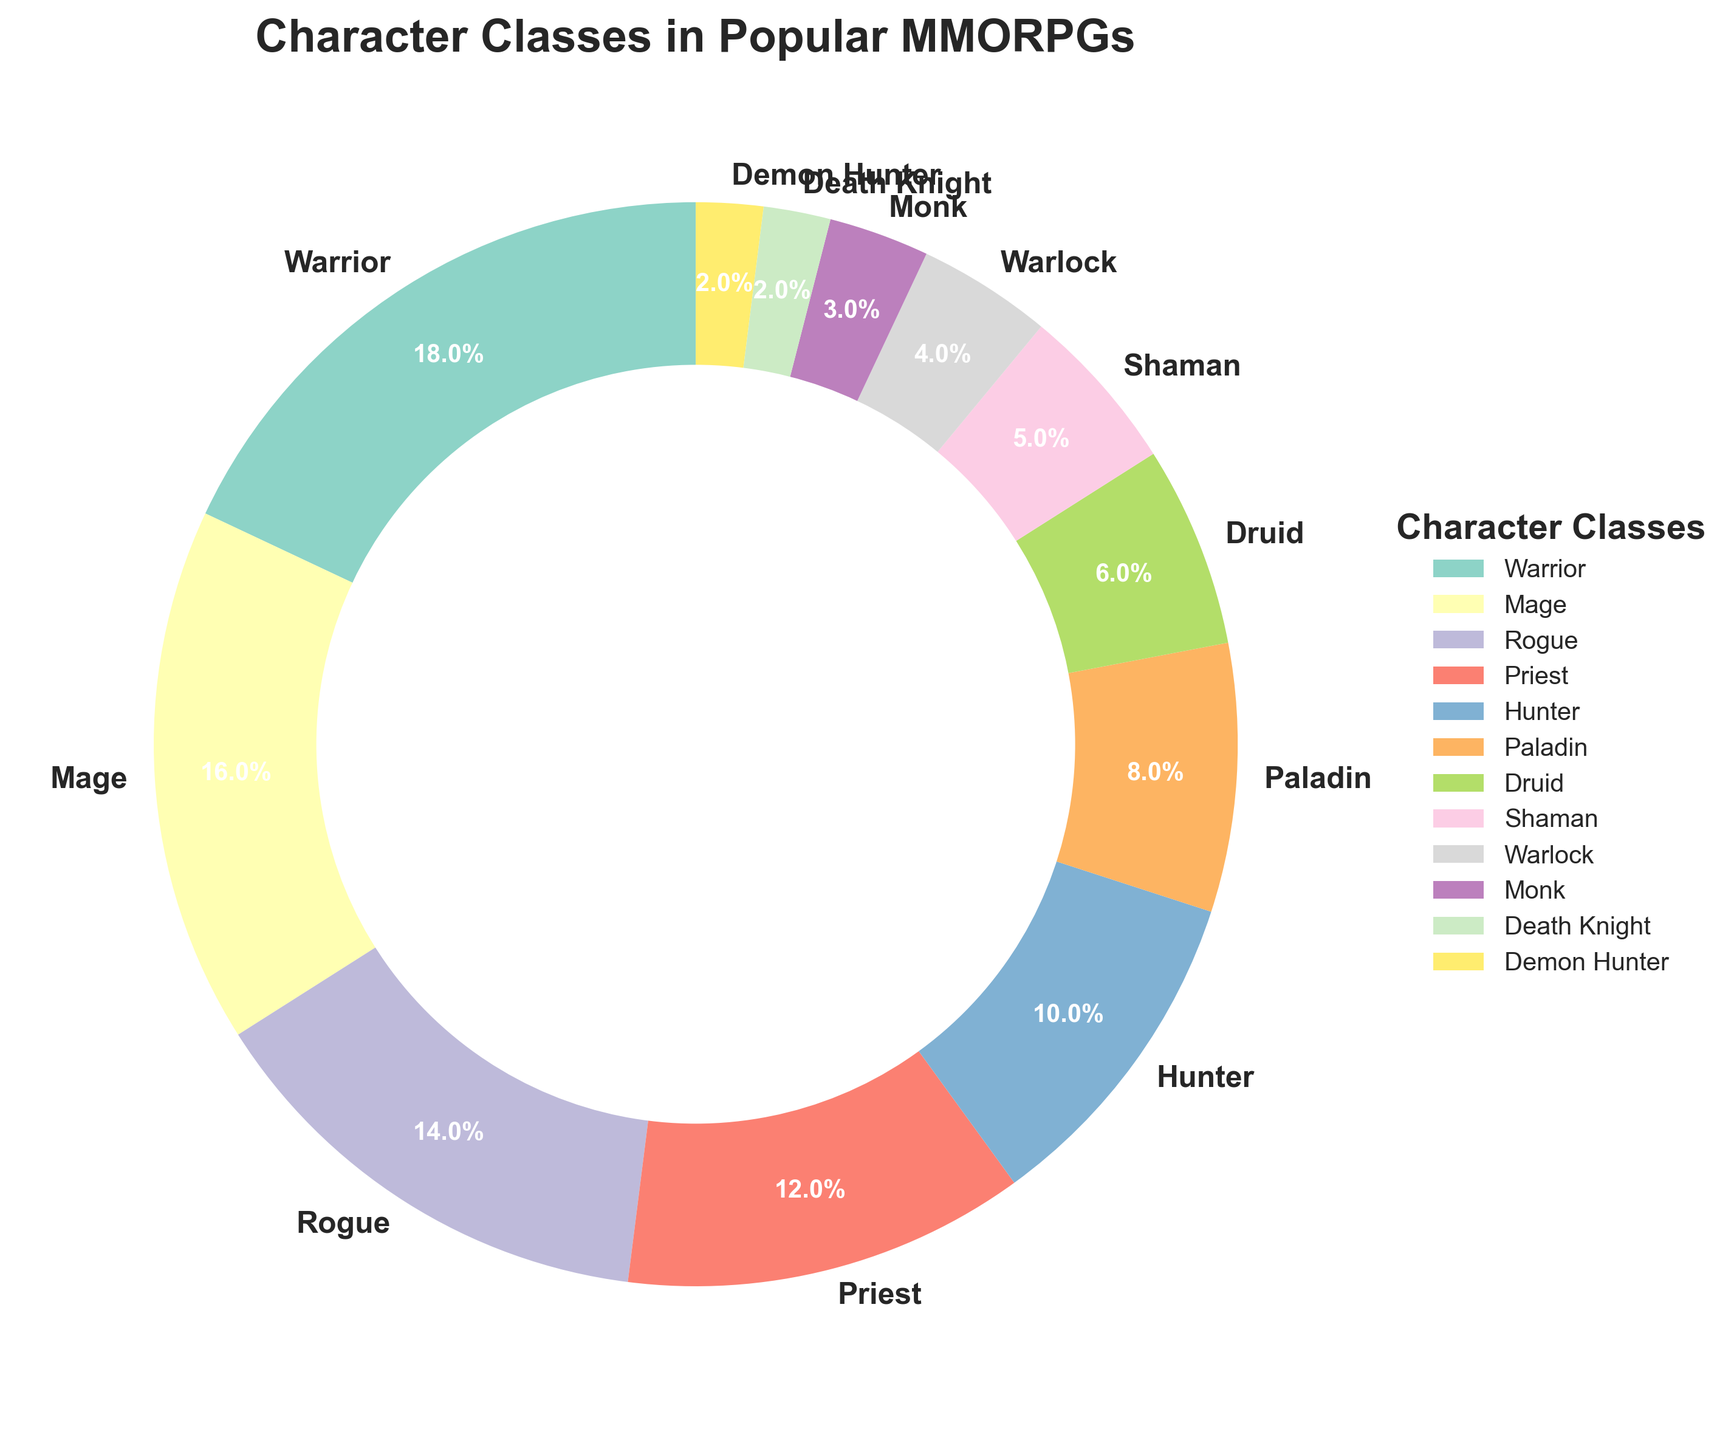What percentage of characters belong to hybrid classes (Druid, Shaman, Monk)? Combine the percentages of Druid (6%), Shaman (5%), and Monk (3%). Sum them up: 6 + 5 + 3 = 14
Answer: 14% Which class has the smallest representation in the MMORPGs? Scan the pie chart for the smallest percentage. The two smallest are Death Knight (2%) and Demon Hunter (2%).
Answer: Death Knight and Demon Hunter How many character classes are represented by a percentage greater than 10%? Identify classes with a percentage greater than 10%: Warrior (18%), Mage (16%), Rogue (14%), Priest (12%). Count them: 4
Answer: 4 What is the total percentage of the top three most represented classes? Identify the top three classes: Warrior (18%), Mage (16%), Rogue (14%). Sum their percentages: 18 + 16 + 14 = 48
Answer: 48% Which class is represented by the color at the 5 o'clock position on the pie chart? Typically, the pie chart starts at 12 o'clock and rotates clockwise. The class around the 5 o'clock position is Monk, which has the smallest segment except for Death Knight and Demon Hunter.
Answer: Monk What is the difference in percentages between the Warrior and Warlock classes? The percentages are Warrior (18%) and Warlock (4%). Subtract Warlock's percentage from Warrior's: 18 - 4 = 14
Answer: 14% Which classes contribute to more than 50% combined? Add percentages starting from the highest until the total exceeds 50%: Warrior (18%) + Mage (16%) + Rogue (14%) + Priest (12%) = 60%
Answer: Warrior, Mage, Rogue, Priest Compare the total percentages of healer-related classes (Priest, Paladin) to warrior-related classes (Warrior, Death Knight). Which has a higher total percentage? Calculate healer-related (Priest 12% + Paladin 8% = 20%) vs. warrior-related (Warrior 18% + Death Knight 2% = 20%). Both groups have the same percentage.
Answer: Equal, both have 20% What is the percentage difference between the combined percentage of ranged classes (Hunter, Mage) and tank classes (Warrior, Paladin)? Ranged classes: Hunter (10%) + Mage (16%) = 26%. Tank classes: Warrior (18%) + Paladin (8%) = 26%. The percentage difference is 26% - 26% = 0%.
Answer: 0% 